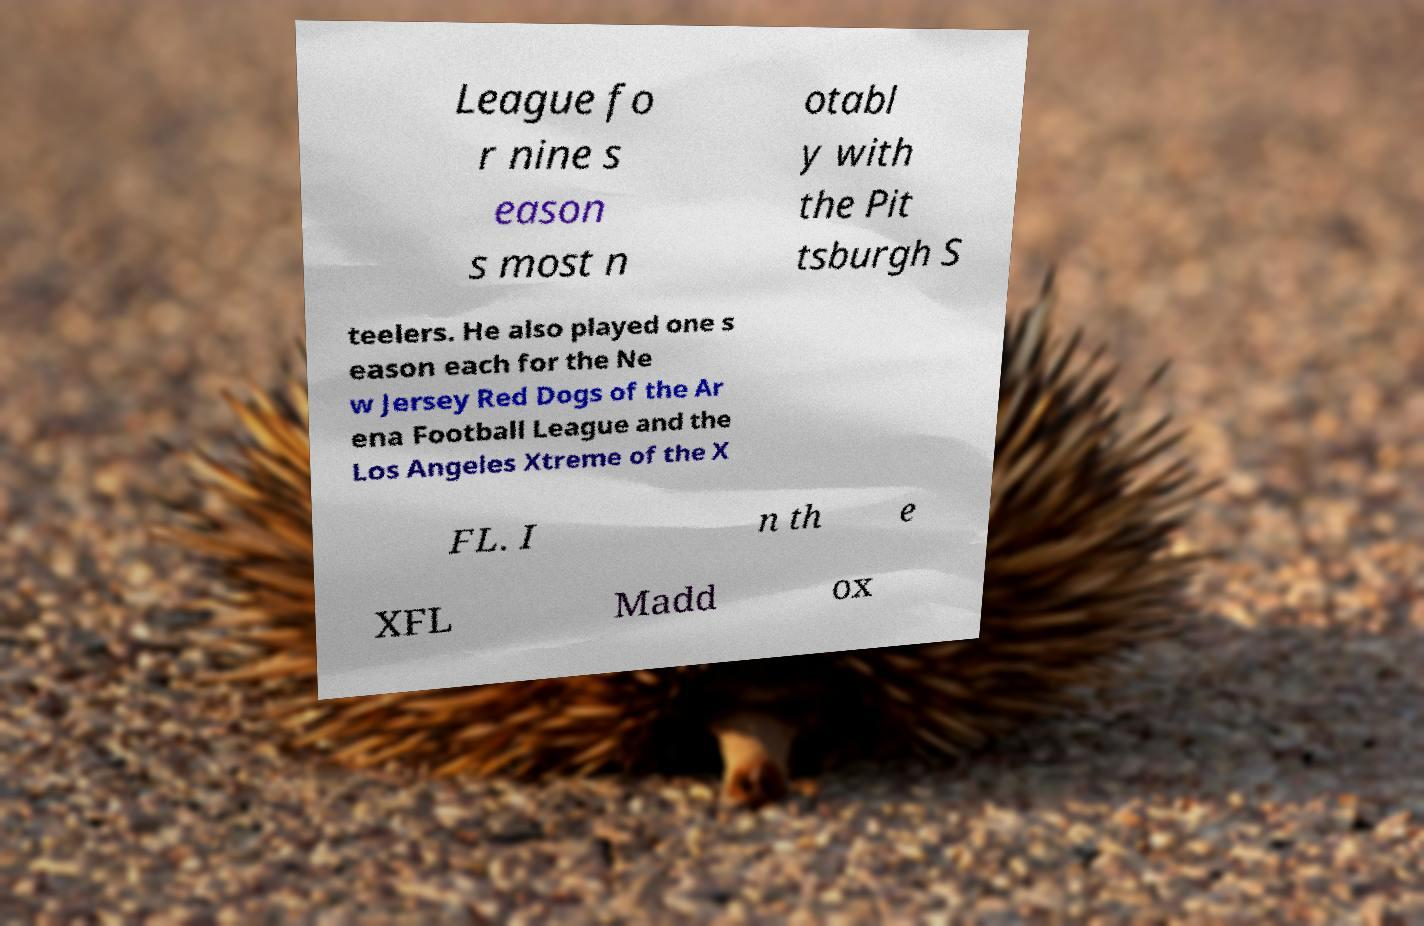Please read and relay the text visible in this image. What does it say? League fo r nine s eason s most n otabl y with the Pit tsburgh S teelers. He also played one s eason each for the Ne w Jersey Red Dogs of the Ar ena Football League and the Los Angeles Xtreme of the X FL. I n th e XFL Madd ox 